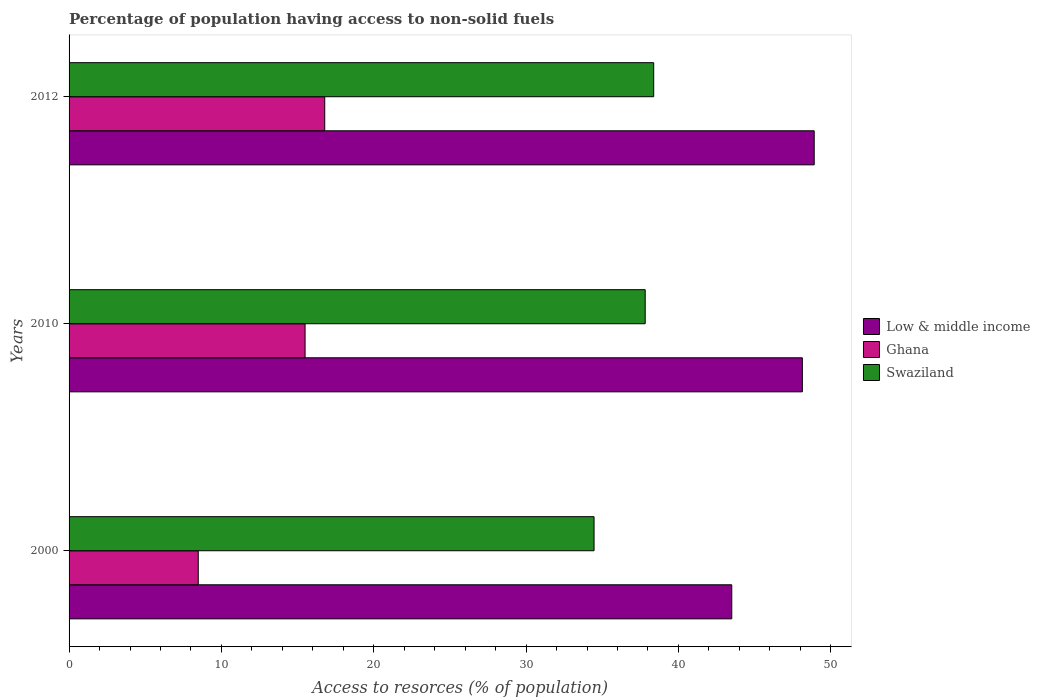How many different coloured bars are there?
Offer a very short reply. 3. How many groups of bars are there?
Your response must be concise. 3. Are the number of bars per tick equal to the number of legend labels?
Ensure brevity in your answer.  Yes. How many bars are there on the 2nd tick from the bottom?
Offer a very short reply. 3. What is the percentage of population having access to non-solid fuels in Ghana in 2000?
Give a very brief answer. 8.48. Across all years, what is the maximum percentage of population having access to non-solid fuels in Swaziland?
Offer a terse response. 38.37. Across all years, what is the minimum percentage of population having access to non-solid fuels in Ghana?
Ensure brevity in your answer.  8.48. What is the total percentage of population having access to non-solid fuels in Low & middle income in the graph?
Your answer should be compact. 140.54. What is the difference between the percentage of population having access to non-solid fuels in Swaziland in 2010 and that in 2012?
Keep it short and to the point. -0.56. What is the difference between the percentage of population having access to non-solid fuels in Low & middle income in 2010 and the percentage of population having access to non-solid fuels in Ghana in 2012?
Give a very brief answer. 31.35. What is the average percentage of population having access to non-solid fuels in Swaziland per year?
Your response must be concise. 36.88. In the year 2000, what is the difference between the percentage of population having access to non-solid fuels in Low & middle income and percentage of population having access to non-solid fuels in Ghana?
Provide a short and direct response. 35.02. What is the ratio of the percentage of population having access to non-solid fuels in Ghana in 2000 to that in 2010?
Provide a short and direct response. 0.55. Is the percentage of population having access to non-solid fuels in Ghana in 2000 less than that in 2012?
Provide a short and direct response. Yes. What is the difference between the highest and the second highest percentage of population having access to non-solid fuels in Swaziland?
Your answer should be very brief. 0.56. What is the difference between the highest and the lowest percentage of population having access to non-solid fuels in Swaziland?
Your answer should be very brief. 3.91. In how many years, is the percentage of population having access to non-solid fuels in Swaziland greater than the average percentage of population having access to non-solid fuels in Swaziland taken over all years?
Offer a very short reply. 2. Is the sum of the percentage of population having access to non-solid fuels in Low & middle income in 2000 and 2012 greater than the maximum percentage of population having access to non-solid fuels in Ghana across all years?
Your response must be concise. Yes. What does the 3rd bar from the bottom in 2000 represents?
Give a very brief answer. Swaziland. Is it the case that in every year, the sum of the percentage of population having access to non-solid fuels in Swaziland and percentage of population having access to non-solid fuels in Ghana is greater than the percentage of population having access to non-solid fuels in Low & middle income?
Offer a terse response. No. How many bars are there?
Provide a short and direct response. 9. Are all the bars in the graph horizontal?
Give a very brief answer. Yes. How many years are there in the graph?
Make the answer very short. 3. What is the difference between two consecutive major ticks on the X-axis?
Offer a terse response. 10. Are the values on the major ticks of X-axis written in scientific E-notation?
Make the answer very short. No. Does the graph contain any zero values?
Offer a very short reply. No. Does the graph contain grids?
Keep it short and to the point. No. Where does the legend appear in the graph?
Give a very brief answer. Center right. How many legend labels are there?
Give a very brief answer. 3. How are the legend labels stacked?
Your answer should be compact. Vertical. What is the title of the graph?
Your response must be concise. Percentage of population having access to non-solid fuels. Does "Fragile and conflict affected situations" appear as one of the legend labels in the graph?
Keep it short and to the point. No. What is the label or title of the X-axis?
Give a very brief answer. Access to resorces (% of population). What is the label or title of the Y-axis?
Ensure brevity in your answer.  Years. What is the Access to resorces (% of population) in Low & middle income in 2000?
Give a very brief answer. 43.5. What is the Access to resorces (% of population) in Ghana in 2000?
Provide a short and direct response. 8.48. What is the Access to resorces (% of population) of Swaziland in 2000?
Keep it short and to the point. 34.46. What is the Access to resorces (% of population) of Low & middle income in 2010?
Give a very brief answer. 48.13. What is the Access to resorces (% of population) in Ghana in 2010?
Your response must be concise. 15.49. What is the Access to resorces (% of population) in Swaziland in 2010?
Keep it short and to the point. 37.82. What is the Access to resorces (% of population) in Low & middle income in 2012?
Your response must be concise. 48.91. What is the Access to resorces (% of population) in Ghana in 2012?
Provide a succinct answer. 16.78. What is the Access to resorces (% of population) of Swaziland in 2012?
Give a very brief answer. 38.37. Across all years, what is the maximum Access to resorces (% of population) of Low & middle income?
Provide a succinct answer. 48.91. Across all years, what is the maximum Access to resorces (% of population) of Ghana?
Offer a very short reply. 16.78. Across all years, what is the maximum Access to resorces (% of population) in Swaziland?
Ensure brevity in your answer.  38.37. Across all years, what is the minimum Access to resorces (% of population) of Low & middle income?
Give a very brief answer. 43.5. Across all years, what is the minimum Access to resorces (% of population) of Ghana?
Offer a very short reply. 8.48. Across all years, what is the minimum Access to resorces (% of population) of Swaziland?
Your response must be concise. 34.46. What is the total Access to resorces (% of population) of Low & middle income in the graph?
Provide a succinct answer. 140.54. What is the total Access to resorces (% of population) in Ghana in the graph?
Offer a terse response. 40.75. What is the total Access to resorces (% of population) in Swaziland in the graph?
Ensure brevity in your answer.  110.65. What is the difference between the Access to resorces (% of population) of Low & middle income in 2000 and that in 2010?
Your answer should be compact. -4.63. What is the difference between the Access to resorces (% of population) of Ghana in 2000 and that in 2010?
Your response must be concise. -7.01. What is the difference between the Access to resorces (% of population) of Swaziland in 2000 and that in 2010?
Make the answer very short. -3.36. What is the difference between the Access to resorces (% of population) in Low & middle income in 2000 and that in 2012?
Make the answer very short. -5.41. What is the difference between the Access to resorces (% of population) of Ghana in 2000 and that in 2012?
Offer a very short reply. -8.3. What is the difference between the Access to resorces (% of population) of Swaziland in 2000 and that in 2012?
Make the answer very short. -3.91. What is the difference between the Access to resorces (% of population) in Low & middle income in 2010 and that in 2012?
Offer a terse response. -0.78. What is the difference between the Access to resorces (% of population) of Ghana in 2010 and that in 2012?
Offer a terse response. -1.29. What is the difference between the Access to resorces (% of population) in Swaziland in 2010 and that in 2012?
Keep it short and to the point. -0.56. What is the difference between the Access to resorces (% of population) of Low & middle income in 2000 and the Access to resorces (% of population) of Ghana in 2010?
Your answer should be very brief. 28.01. What is the difference between the Access to resorces (% of population) of Low & middle income in 2000 and the Access to resorces (% of population) of Swaziland in 2010?
Your answer should be compact. 5.68. What is the difference between the Access to resorces (% of population) in Ghana in 2000 and the Access to resorces (% of population) in Swaziland in 2010?
Offer a very short reply. -29.34. What is the difference between the Access to resorces (% of population) of Low & middle income in 2000 and the Access to resorces (% of population) of Ghana in 2012?
Offer a very short reply. 26.72. What is the difference between the Access to resorces (% of population) of Low & middle income in 2000 and the Access to resorces (% of population) of Swaziland in 2012?
Your answer should be compact. 5.12. What is the difference between the Access to resorces (% of population) of Ghana in 2000 and the Access to resorces (% of population) of Swaziland in 2012?
Ensure brevity in your answer.  -29.9. What is the difference between the Access to resorces (% of population) of Low & middle income in 2010 and the Access to resorces (% of population) of Ghana in 2012?
Your response must be concise. 31.35. What is the difference between the Access to resorces (% of population) in Low & middle income in 2010 and the Access to resorces (% of population) in Swaziland in 2012?
Provide a succinct answer. 9.76. What is the difference between the Access to resorces (% of population) in Ghana in 2010 and the Access to resorces (% of population) in Swaziland in 2012?
Offer a terse response. -22.88. What is the average Access to resorces (% of population) in Low & middle income per year?
Your answer should be compact. 46.85. What is the average Access to resorces (% of population) in Ghana per year?
Provide a short and direct response. 13.58. What is the average Access to resorces (% of population) in Swaziland per year?
Offer a terse response. 36.88. In the year 2000, what is the difference between the Access to resorces (% of population) in Low & middle income and Access to resorces (% of population) in Ghana?
Offer a very short reply. 35.02. In the year 2000, what is the difference between the Access to resorces (% of population) in Low & middle income and Access to resorces (% of population) in Swaziland?
Give a very brief answer. 9.04. In the year 2000, what is the difference between the Access to resorces (% of population) of Ghana and Access to resorces (% of population) of Swaziland?
Provide a short and direct response. -25.98. In the year 2010, what is the difference between the Access to resorces (% of population) in Low & middle income and Access to resorces (% of population) in Ghana?
Offer a very short reply. 32.64. In the year 2010, what is the difference between the Access to resorces (% of population) in Low & middle income and Access to resorces (% of population) in Swaziland?
Your answer should be very brief. 10.32. In the year 2010, what is the difference between the Access to resorces (% of population) of Ghana and Access to resorces (% of population) of Swaziland?
Your answer should be very brief. -22.33. In the year 2012, what is the difference between the Access to resorces (% of population) of Low & middle income and Access to resorces (% of population) of Ghana?
Provide a short and direct response. 32.13. In the year 2012, what is the difference between the Access to resorces (% of population) of Low & middle income and Access to resorces (% of population) of Swaziland?
Provide a short and direct response. 10.54. In the year 2012, what is the difference between the Access to resorces (% of population) in Ghana and Access to resorces (% of population) in Swaziland?
Offer a terse response. -21.59. What is the ratio of the Access to resorces (% of population) of Low & middle income in 2000 to that in 2010?
Ensure brevity in your answer.  0.9. What is the ratio of the Access to resorces (% of population) in Ghana in 2000 to that in 2010?
Ensure brevity in your answer.  0.55. What is the ratio of the Access to resorces (% of population) in Swaziland in 2000 to that in 2010?
Make the answer very short. 0.91. What is the ratio of the Access to resorces (% of population) in Low & middle income in 2000 to that in 2012?
Your answer should be compact. 0.89. What is the ratio of the Access to resorces (% of population) of Ghana in 2000 to that in 2012?
Give a very brief answer. 0.51. What is the ratio of the Access to resorces (% of population) of Swaziland in 2000 to that in 2012?
Offer a terse response. 0.9. What is the ratio of the Access to resorces (% of population) in Low & middle income in 2010 to that in 2012?
Offer a terse response. 0.98. What is the ratio of the Access to resorces (% of population) of Swaziland in 2010 to that in 2012?
Provide a succinct answer. 0.99. What is the difference between the highest and the second highest Access to resorces (% of population) in Low & middle income?
Give a very brief answer. 0.78. What is the difference between the highest and the second highest Access to resorces (% of population) of Ghana?
Provide a short and direct response. 1.29. What is the difference between the highest and the second highest Access to resorces (% of population) of Swaziland?
Provide a short and direct response. 0.56. What is the difference between the highest and the lowest Access to resorces (% of population) in Low & middle income?
Make the answer very short. 5.41. What is the difference between the highest and the lowest Access to resorces (% of population) in Ghana?
Offer a very short reply. 8.3. What is the difference between the highest and the lowest Access to resorces (% of population) of Swaziland?
Give a very brief answer. 3.91. 